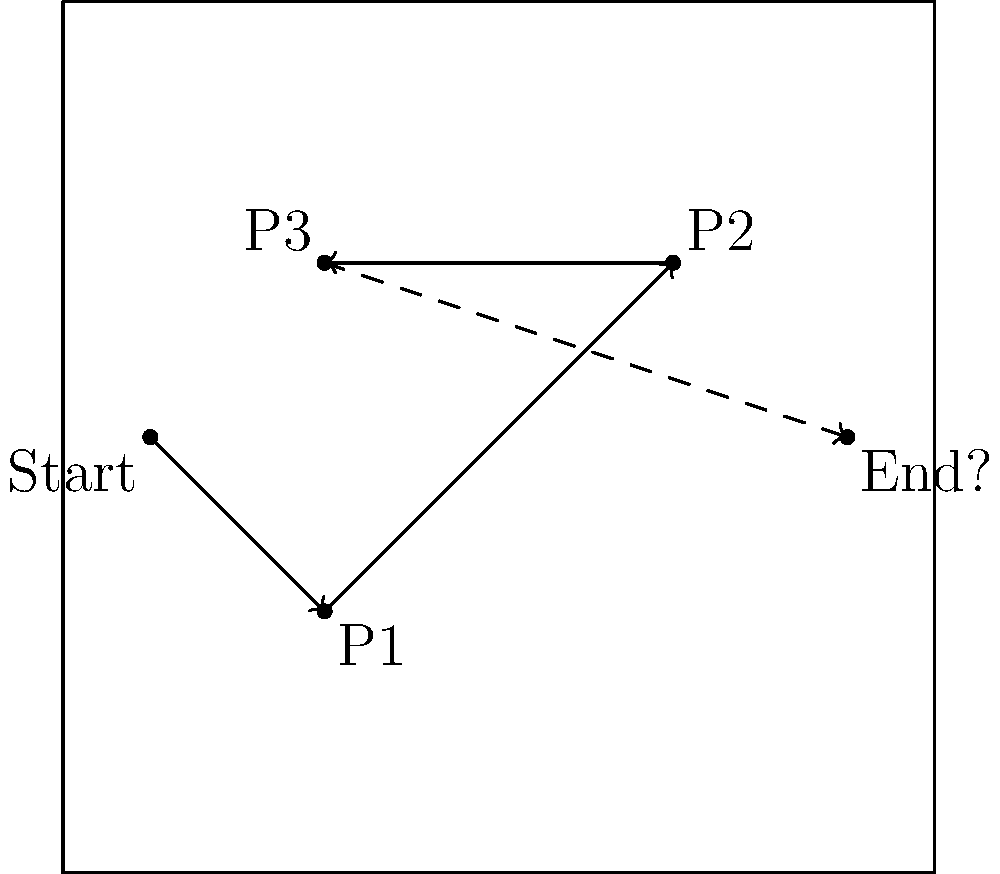In this soccer field diagram, a ball is kicked from the "Start" position and deflects off three players (P1, P2, and P3) in sequence. Assuming perfect elastic collisions and ignoring factors like spin and air resistance, which of the following best describes the ball's final trajectory after bouncing off P3?

A) The ball will continue in a straight line towards the "End?" point.
B) The ball will curve upwards, ending above the "End?" point.
C) The ball will curve downwards, ending below the "End?" point.
D) The ball will reverse direction, moving back towards the left side of the field. To solve this problem, we need to consider the principles of elastic collisions and the law of reflection. Let's analyze the ball's path step by step:

1) The ball starts moving from "Start" to P1 in a straight line.

2) At P1, the ball collides and reflects. According to the law of reflection, the angle of incidence equals the angle of reflection. The ball then moves from P1 to P2.

3) At P2, another collision occurs. Again, the angle of incidence equals the angle of reflection. The ball now moves from P2 to P3.

4) At P3, the final collision takes place. Once more, the angle of incidence will equal the angle of reflection.

5) Observing the pattern of reflections, we can see that each collision causes the ball to change direction, but maintains a consistent angle pattern.

6) After the final collision at P3, if we extend the trajectory, we can see that it would form a straight line towards the "End?" point.

This is because the series of collisions has created a symmetrical path, with P2 acting as the apex of the trajectory. The final segment (P3 to End?) mirrors the initial segment (Start to P1) in terms of angle and direction.

Therefore, assuming perfect elastic collisions and ignoring real-world factors like spin and air resistance, the ball would continue in a straight line towards the "End?" point after bouncing off P3.
Answer: A 